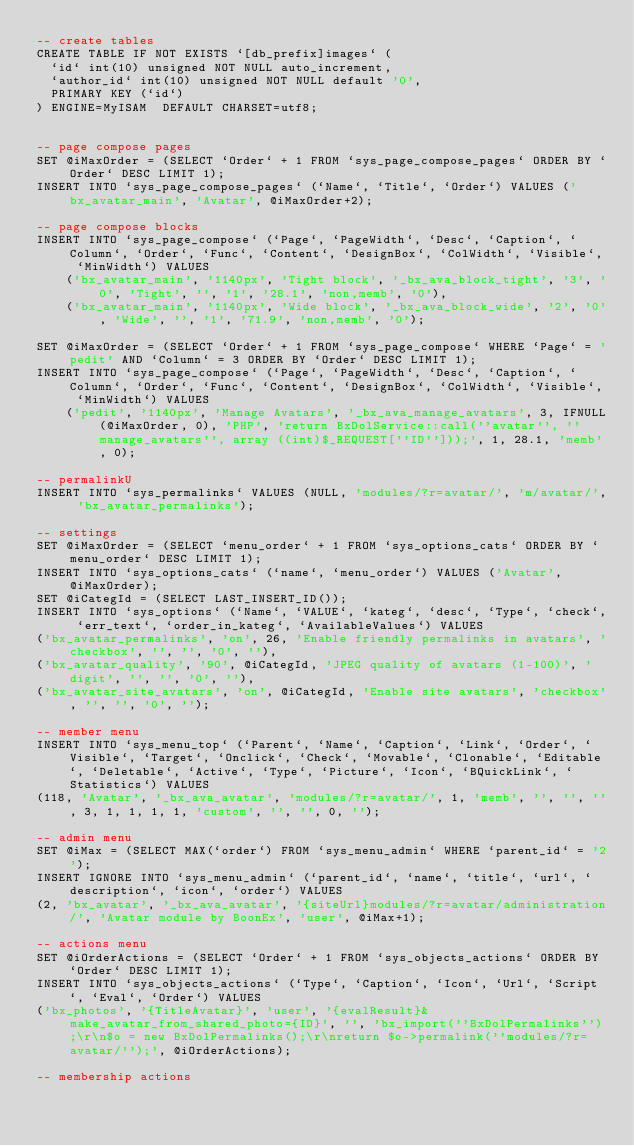Convert code to text. <code><loc_0><loc_0><loc_500><loc_500><_SQL_>-- create tables
CREATE TABLE IF NOT EXISTS `[db_prefix]images` (
  `id` int(10) unsigned NOT NULL auto_increment,
  `author_id` int(10) unsigned NOT NULL default '0',
  PRIMARY KEY (`id`)
) ENGINE=MyISAM  DEFAULT CHARSET=utf8;


-- page compose pages
SET @iMaxOrder = (SELECT `Order` + 1 FROM `sys_page_compose_pages` ORDER BY `Order` DESC LIMIT 1);
INSERT INTO `sys_page_compose_pages` (`Name`, `Title`, `Order`) VALUES ('bx_avatar_main', 'Avatar', @iMaxOrder+2);

-- page compose blocks
INSERT INTO `sys_page_compose` (`Page`, `PageWidth`, `Desc`, `Caption`, `Column`, `Order`, `Func`, `Content`, `DesignBox`, `ColWidth`, `Visible`, `MinWidth`) VALUES 
    ('bx_avatar_main', '1140px', 'Tight block', '_bx_ava_block_tight', '3', '0', 'Tight', '', '1', '28.1', 'non,memb', '0'),
    ('bx_avatar_main', '1140px', 'Wide block', '_bx_ava_block_wide', '2', '0', 'Wide', '', '1', '71.9', 'non,memb', '0');

SET @iMaxOrder = (SELECT `Order` + 1 FROM `sys_page_compose` WHERE `Page` = 'pedit' AND `Column` = 3 ORDER BY `Order` DESC LIMIT 1);
INSERT INTO `sys_page_compose` (`Page`, `PageWidth`, `Desc`, `Caption`, `Column`, `Order`, `Func`, `Content`, `DesignBox`, `ColWidth`, `Visible`, `MinWidth`) VALUES
    ('pedit', '1140px', 'Manage Avatars', '_bx_ava_manage_avatars', 3, IFNULL(@iMaxOrder, 0), 'PHP', 'return BxDolService::call(''avatar'', ''manage_avatars'', array ((int)$_REQUEST[''ID'']));', 1, 28.1, 'memb', 0);

-- permalinkU
INSERT INTO `sys_permalinks` VALUES (NULL, 'modules/?r=avatar/', 'm/avatar/', 'bx_avatar_permalinks');

-- settings
SET @iMaxOrder = (SELECT `menu_order` + 1 FROM `sys_options_cats` ORDER BY `menu_order` DESC LIMIT 1);
INSERT INTO `sys_options_cats` (`name`, `menu_order`) VALUES ('Avatar', @iMaxOrder);
SET @iCategId = (SELECT LAST_INSERT_ID());
INSERT INTO `sys_options` (`Name`, `VALUE`, `kateg`, `desc`, `Type`, `check`, `err_text`, `order_in_kateg`, `AvailableValues`) VALUES
('bx_avatar_permalinks', 'on', 26, 'Enable friendly permalinks in avatars', 'checkbox', '', '', '0', ''),
('bx_avatar_quality', '90', @iCategId, 'JPEG quality of avatars (1-100)', 'digit', '', '', '0', ''),
('bx_avatar_site_avatars', 'on', @iCategId, 'Enable site avatars', 'checkbox', '', '', '0', '');

-- member menu
INSERT INTO `sys_menu_top` (`Parent`, `Name`, `Caption`, `Link`, `Order`, `Visible`, `Target`, `Onclick`, `Check`, `Movable`, `Clonable`, `Editable`, `Deletable`, `Active`, `Type`, `Picture`, `Icon`, `BQuickLink`, `Statistics`) VALUES 
(118, 'Avatar', '_bx_ava_avatar', 'modules/?r=avatar/', 1, 'memb', '', '', '', 3, 1, 1, 1, 1, 'custom', '', '', 0, '');

-- admin menu
SET @iMax = (SELECT MAX(`order`) FROM `sys_menu_admin` WHERE `parent_id` = '2');
INSERT IGNORE INTO `sys_menu_admin` (`parent_id`, `name`, `title`, `url`, `description`, `icon`, `order`) VALUES
(2, 'bx_avatar', '_bx_ava_avatar', '{siteUrl}modules/?r=avatar/administration/', 'Avatar module by BoonEx', 'user', @iMax+1);

-- actions menu
SET @iOrderActions = (SELECT `Order` + 1 FROM `sys_objects_actions` ORDER BY `Order` DESC LIMIT 1);
INSERT INTO `sys_objects_actions` (`Type`, `Caption`, `Icon`, `Url`, `Script`, `Eval`, `Order`) VALUES
('bx_photos', '{TitleAvatar}', 'user', '{evalResult}&make_avatar_from_shared_photo={ID}', '', 'bx_import(''BxDolPermalinks'');\r\n$o = new BxDolPermalinks();\r\nreturn $o->permalink(''modules/?r=avatar/'');', @iOrderActions);

-- membership actions</code> 